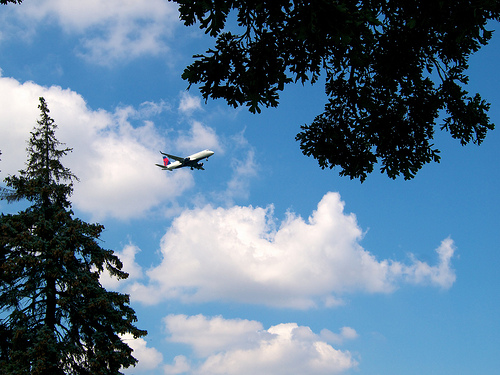What kind of plane is shown in the picture? The image shows a commercial airliner, which can be identified by its characteristic fuselage shape, wing placement, and tail design. 